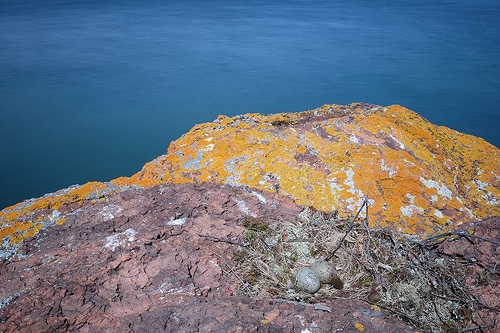<image>
Can you confirm if the hill one is in front of the hill two? Yes. The hill one is positioned in front of the hill two, appearing closer to the camera viewpoint. 